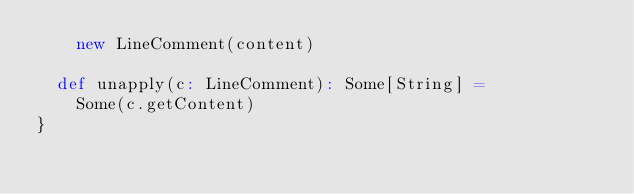<code> <loc_0><loc_0><loc_500><loc_500><_Scala_>    new LineComment(content)

  def unapply(c: LineComment): Some[String] =
    Some(c.getContent)
}
</code> 